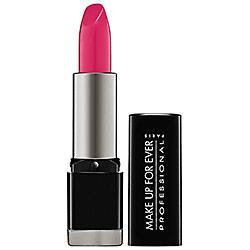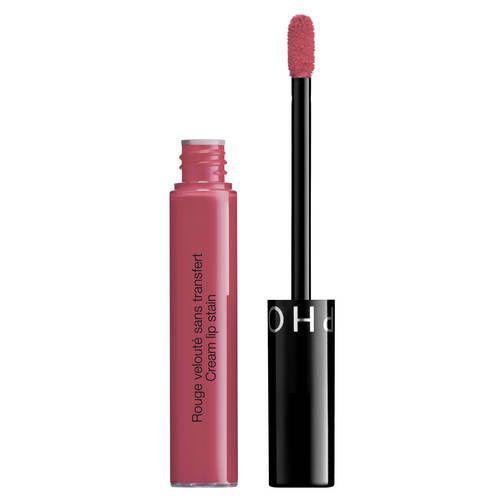The first image is the image on the left, the second image is the image on the right. Assess this claim about the two images: "One of the images shows a foam-tipped lip applicator.". Correct or not? Answer yes or no. Yes. 